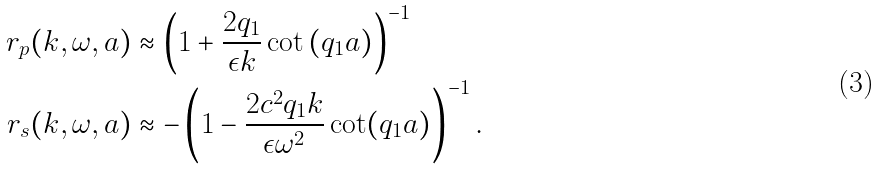<formula> <loc_0><loc_0><loc_500><loc_500>r _ { p } ( k , \omega , a ) & \approx \left ( 1 + \frac { 2 q _ { 1 } } { \epsilon k } \cot \left ( q _ { 1 } a \right ) \right ) ^ { - 1 } \\ r _ { s } ( k , \omega , a ) & \approx - \left ( 1 - \frac { 2 c ^ { 2 } q _ { 1 } k } { \epsilon \omega ^ { 2 } } \cot ( q _ { 1 } a ) \right ) ^ { - 1 } .</formula> 